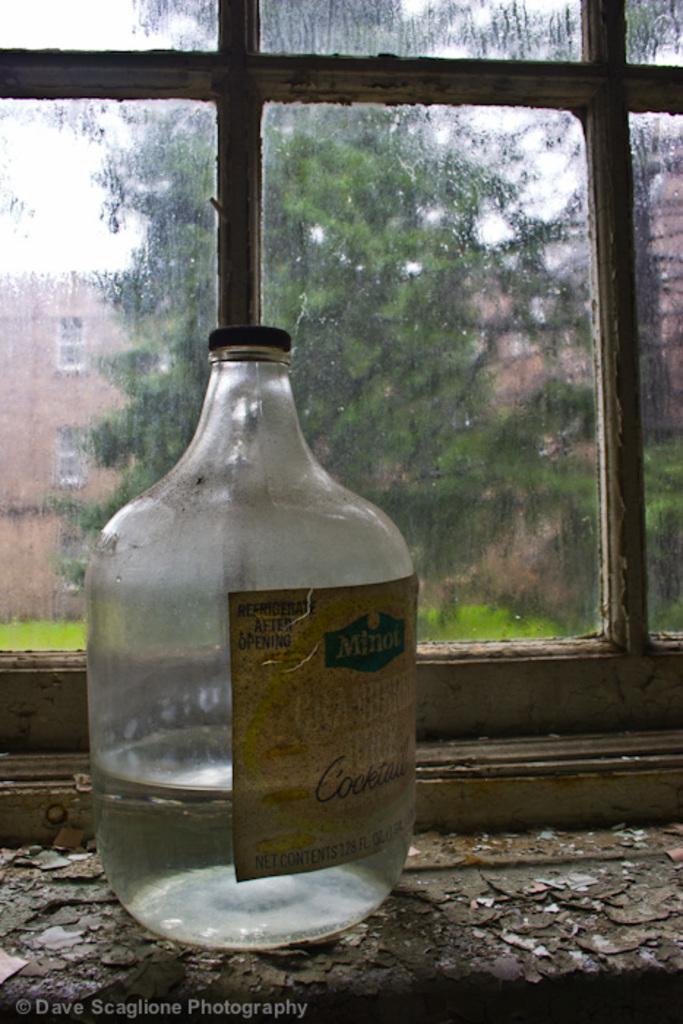What brand is the product in the glass container?
Offer a very short reply. Minot. 